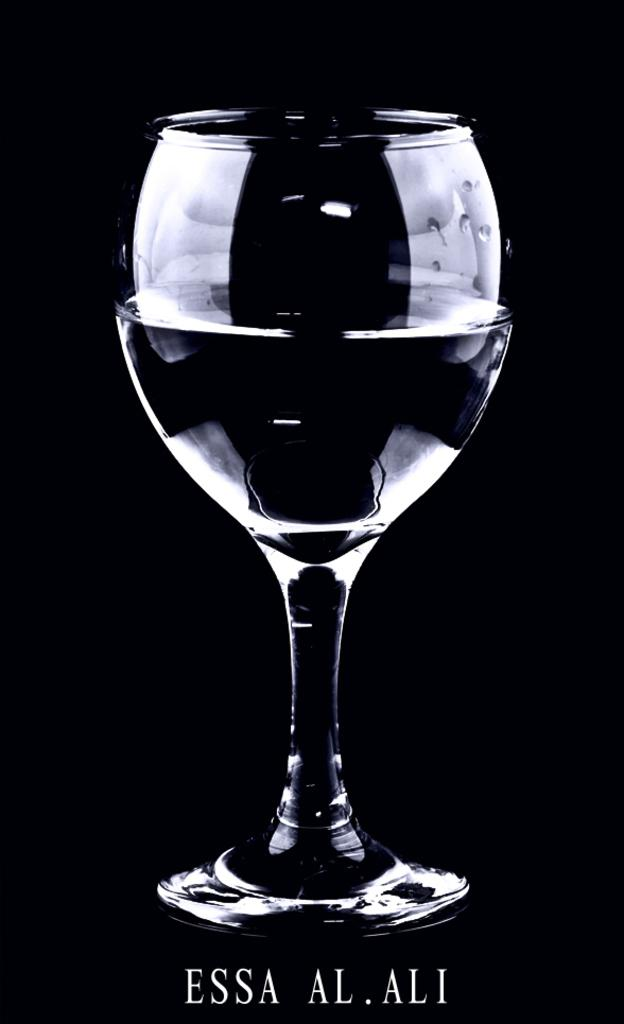What is contained in the glass that is visible in the image? There is a drink in the glass that is visible in the image. What can be observed about the background of the image? The background of the image appears to be black. Is there any text present in the image? Yes, there is some text visible at the bottom of the image. What type of appliance is being approved in the image? There is no appliance or approval process depicted in the image. How many minutes does the text at the bottom of the image indicate? The text at the bottom of the image does not mention any specific time or duration, such as minutes. 